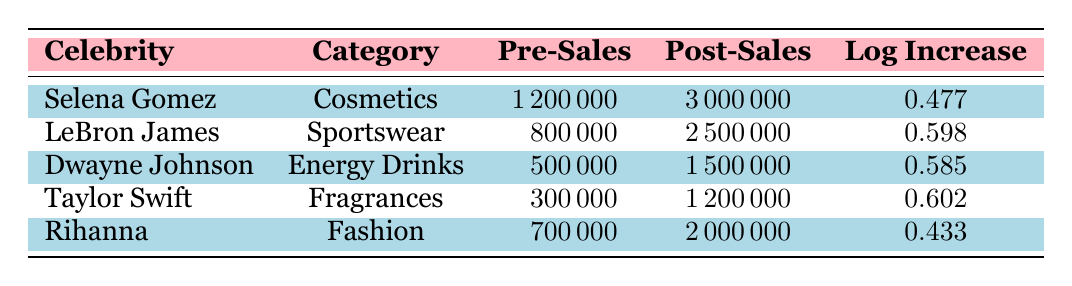What celebrity endorsed the Energy Drinks category? By looking at the table, the celebrity associated with the Energy Drinks product category is Dwayne Johnson.
Answer: Dwayne Johnson Which product category had the highest pre-endorsement sales? The pre-endorsement sales figures are: Cosmetics (1200000), Sportswear (800000), Energy Drinks (500000), Fragrances (300000), and Fashion (700000). The highest value is 1200000 in the Cosmetics category.
Answer: Cosmetics What was the post-endorsement sales figure for Rihanna's endorsed products? According to the table, Rihanna's post-endorsement sales for the Fashion category is 2000000.
Answer: 2000000 Calculate the total increase in sales for all product categories combined after endorsements. Total post-endorsement sales: 3000000 (Cosmetics) + 2500000 (Sportswear) + 1500000 (Energy Drinks) + 1200000 (Fragrances) + 2000000 (Fashion) = 11250000. Total pre-endorsement sales: 1200000 + 800000 + 500000 + 300000 + 700000 = 3200000. Therefore, the total increase is 11250000 - 3200000 = 8050000.
Answer: 8050000 Is the logarithmic increase more than 0.5 for any product category? Looking at the logarithmic increase values: 0.477 (Cosmetics), 0.598 (Sportswear), 0.585 (Energy Drinks), 0.602 (Fragrances), and 0.433 (Fashion). The values for Sportswear, Energy Drinks, and Fragrances are all greater than 0.5.
Answer: Yes Which celebrity had the smallest logarithmic increase in sales? Examining the logarithmic increase values, Rihanna has the lowest value at 0.433.
Answer: Rihanna 